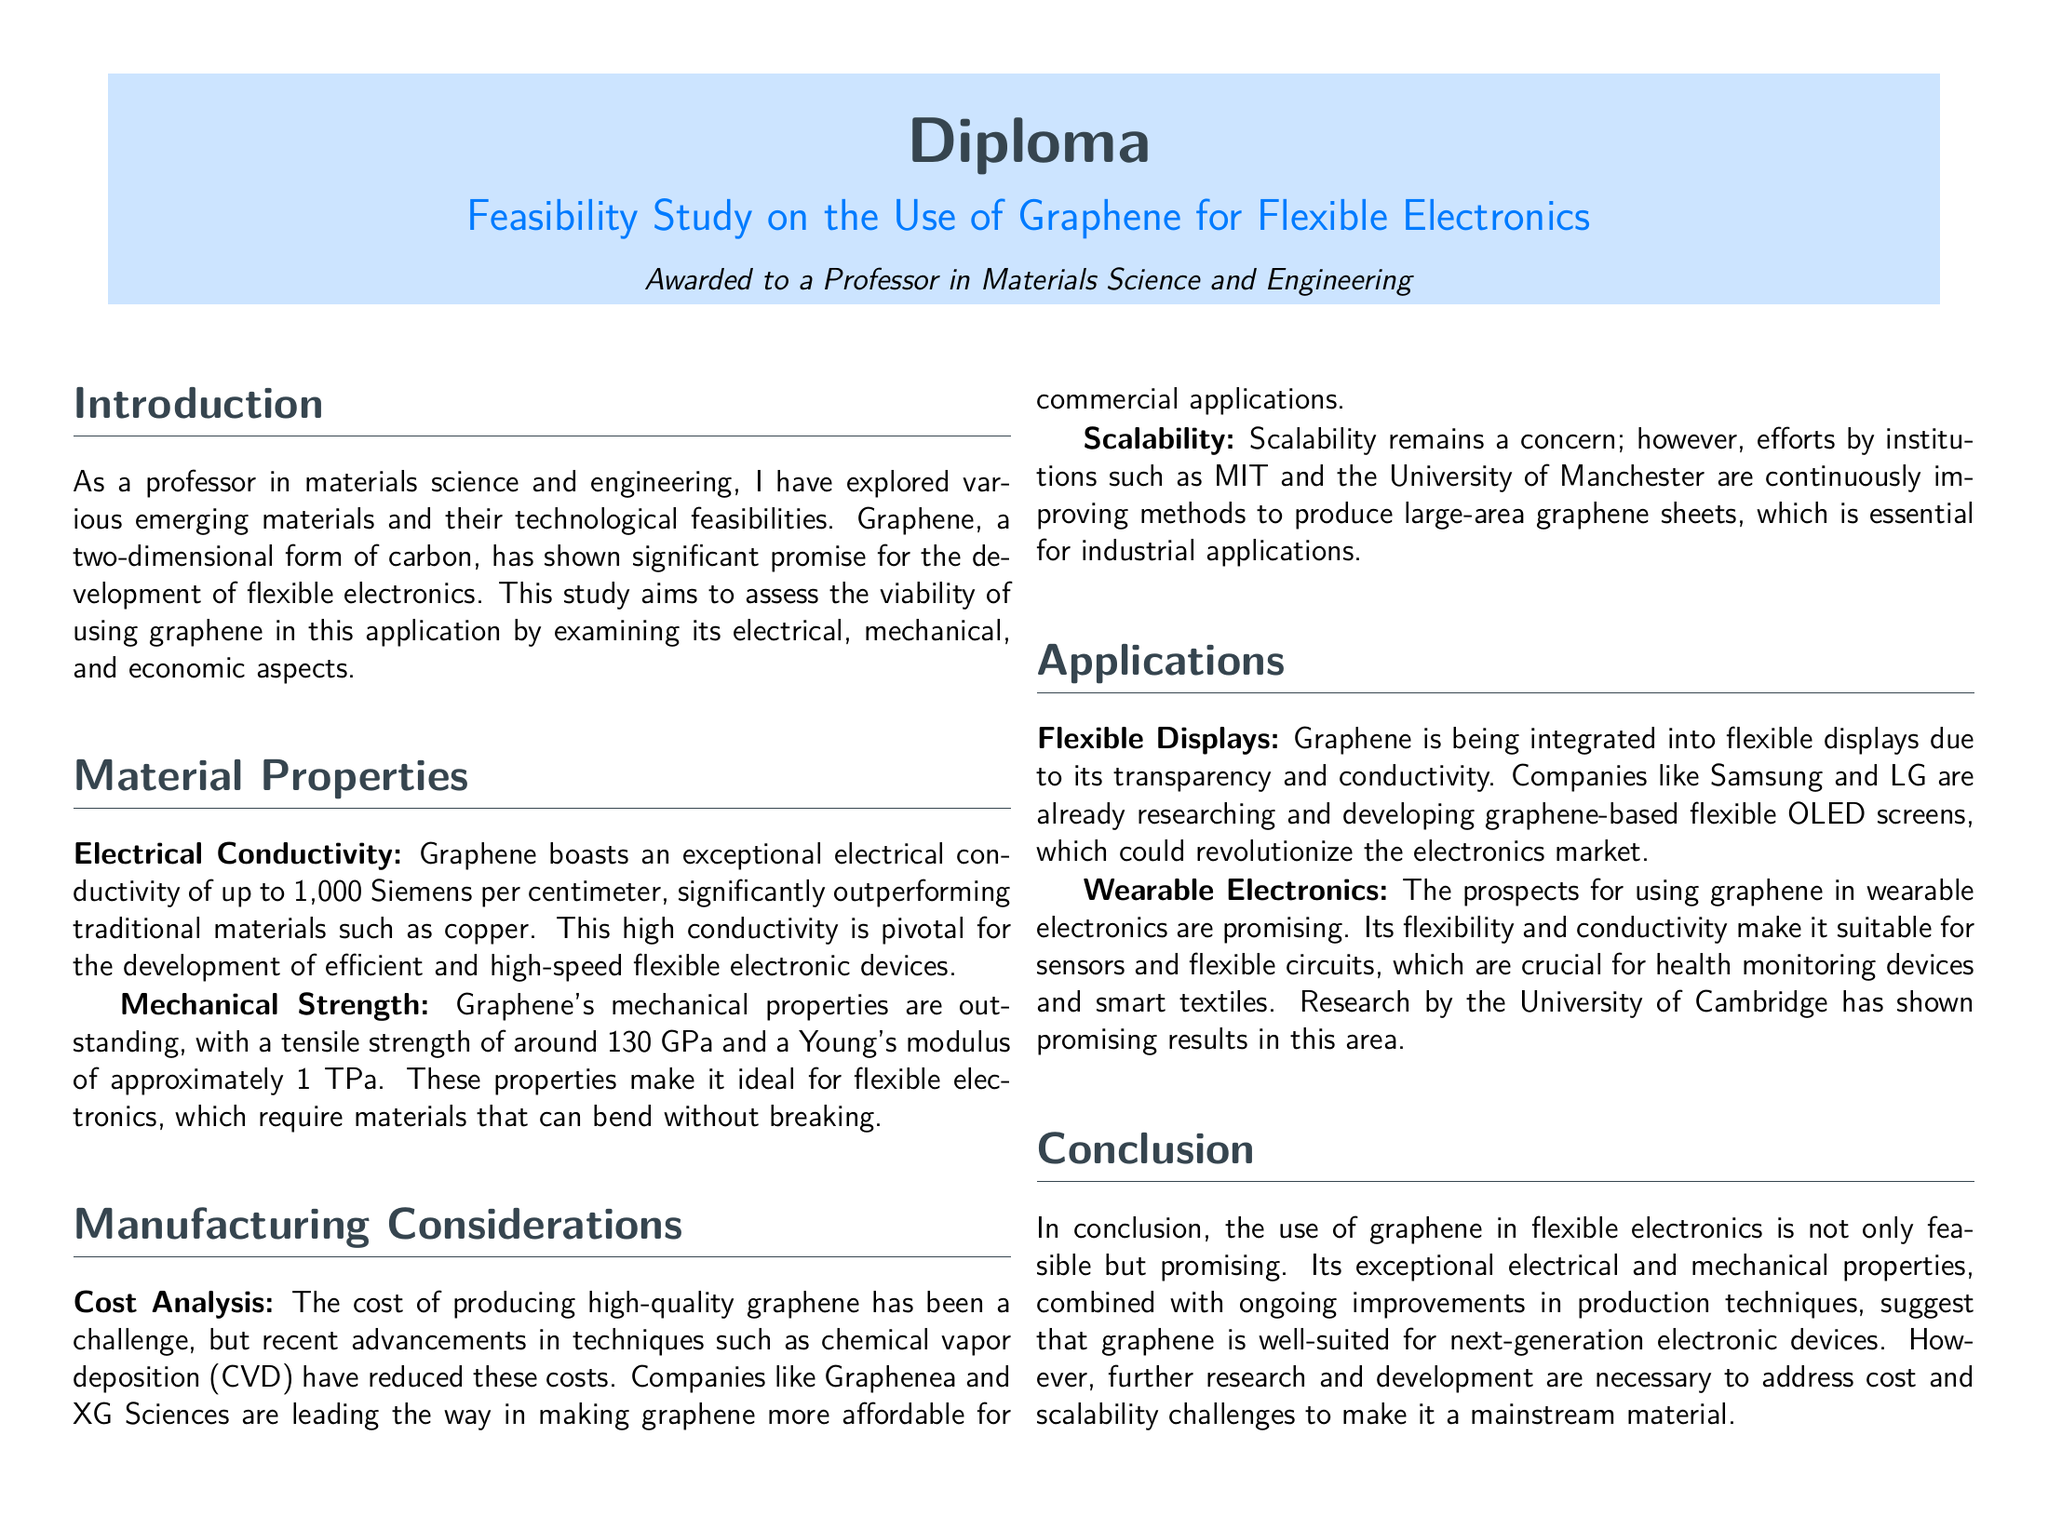What is the title of the diploma? The title of the diploma is clearly mentioned in the document as "Feasibility Study on the Use of Graphene for Flexible Electronics."
Answer: Feasibility Study on the Use of Graphene for Flexible Electronics What is the tensile strength of graphene? The document lists graphene's tensile strength as approximately 130 GPa.
Answer: 130 GPa Which two companies are mentioned as leaders in making graphene more affordable? The document specifically mentions Graphenea and XG Sciences as leading companies in graphene production.
Answer: Graphenea and XG Sciences What is one application of graphene mentioned in the document? The document lists "Flexible Displays" as one of the applications of graphene in electronics.
Answer: Flexible Displays What is the Young's modulus of graphene? According to the document, the Young's modulus of graphene is approximately 1 TPa.
Answer: 1 TPa Which university is involved in improving graphene production? The document mentions that the University of Manchester is involved in improving methods of graphene production.
Answer: University of Manchester What property of graphene makes it suitable for wearable electronics? The document states that graphene's flexibility and conductivity make it suitable for wearable electronics.
Answer: Flexibility and conductivity What challenge regarding graphene is highlighted in the manufacturing section? The document highlights "Cost Analysis" as a significant challenge in producing high-quality graphene.
Answer: Cost Analysis What is the main conclusion about graphene's use in electronics? The main conclusion indicates that the use of graphene in flexible electronics is promising and feasible.
Answer: Promising and feasible 